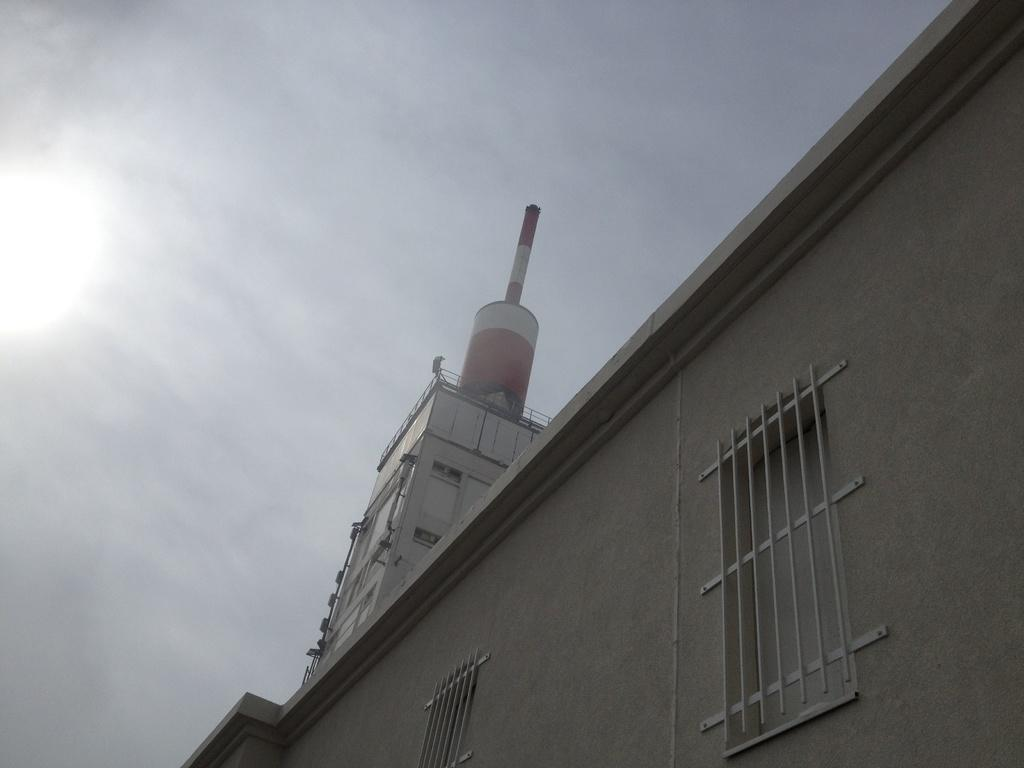What type of structure is present in the image? There is a building in the image. What can be seen in the background of the image? The sky is visible in the background of the image. What type of eggnog is being offered by the building in the image? There is no eggnog present in the image, and the building is not offering anything. 